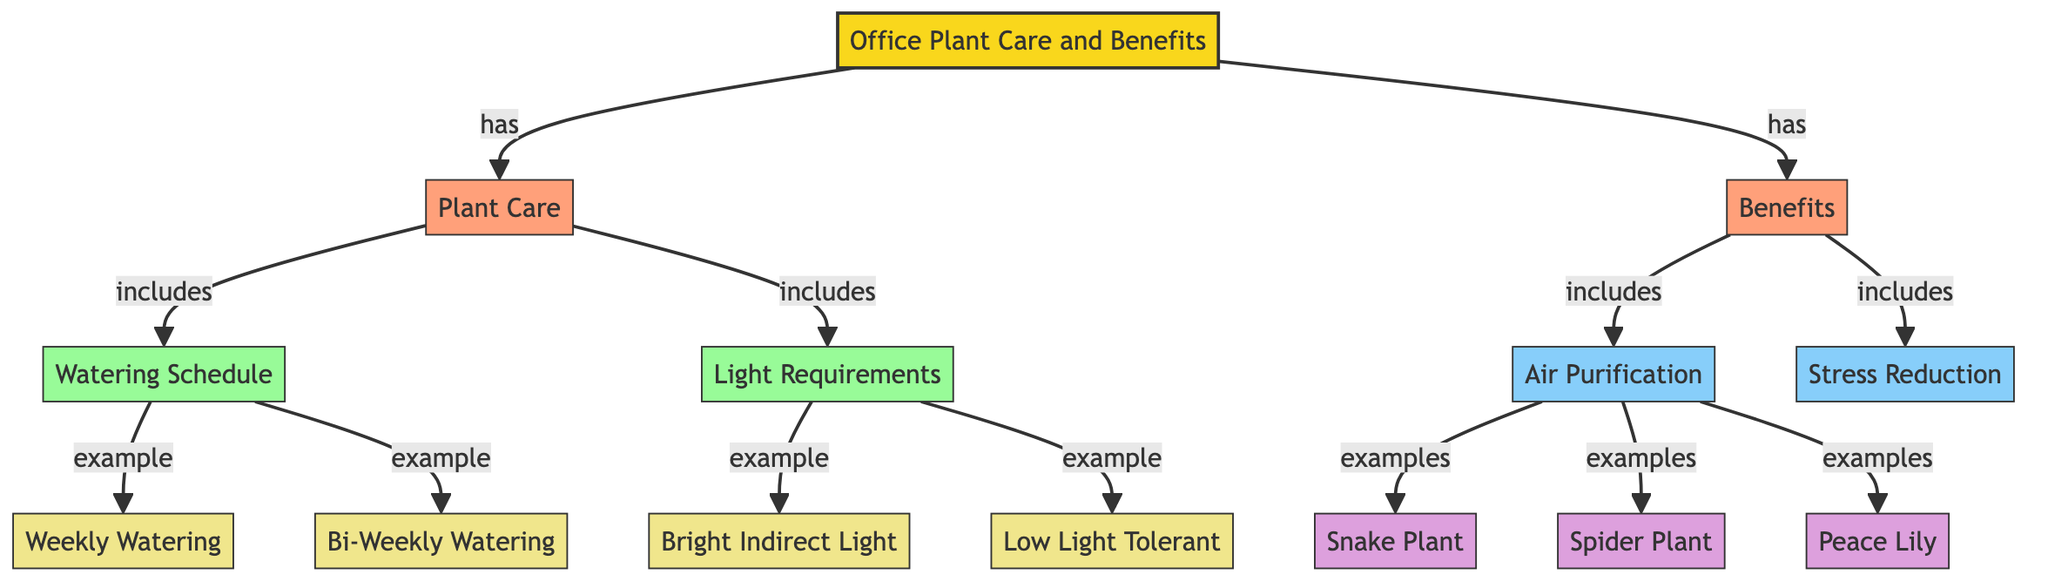What are the categories included in the diagram? The diagram includes two main categories, "Plant Care" and "Benefits," which are directly associated with the root node "Office Plant Care and Benefits."
Answer: Plant Care, Benefits How many examples of air-purifying plants are listed? The air-purification section lists three example plants: Snake Plant, Spider Plant, and Peace Lily. This is determined by counting the nodes directly connected to "Air Purification."
Answer: 3 What type of light does the "Light Requirements" subcategory include? The "Light Requirements" subcategory includes two types of light descriptions: "Bright Indirect Light" and "Low Light Tolerant." These are the details under the subcategory node.
Answer: Bright Indirect Light, Low Light Tolerant What is the watering frequency for the example listed under the watering schedule? The diagram lists two watering schedules as examples, "Weekly Watering" and "Bi-Weekly Watering." Since "Weekly Watering" is specifically highlighted as an example under "Watering Schedule," this is the chosen frequency for some plants.
Answer: Weekly Watering Which benefit does the diagram state can help reduce stress? The diagram specifically notes "Stress Reduction" as one of the benefits, indicating its impact on the office environment. This is established under the "Benefits" category directly linked to the root node.
Answer: Stress Reduction What are the two watering examples for plant care? Under the "Watering Schedule" subcategory, the diagram lists "Weekly Watering" and "Bi-Weekly Watering" as the two examples, which can be observed in their connection to the watering schedule node.
Answer: Weekly Watering, Bi-Weekly Watering Which category is associated with air purification? The "Air Purification" section falls under the "Benefits" category, which indicates its relationship to the positive aspects of having plants in the office. This is shown by the connection between "Benefits" and "Air Purification."
Answer: Benefits What is the relationship between "Plant Care" and "Benefits"? The relationship is that "Plant Care" and "Benefits" are both primary categories stemming from the central node, indicating a direct connection where each influences the office environment positively.
Answer: has 